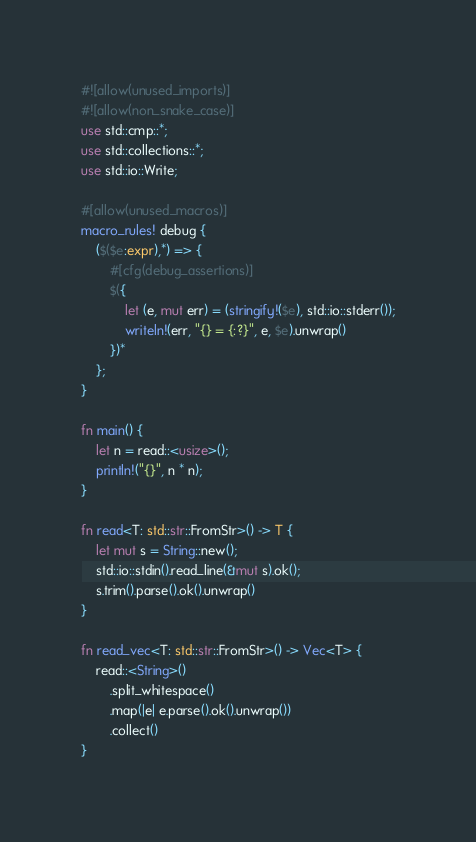Convert code to text. <code><loc_0><loc_0><loc_500><loc_500><_Rust_>#![allow(unused_imports)]
#![allow(non_snake_case)]
use std::cmp::*;
use std::collections::*;
use std::io::Write;

#[allow(unused_macros)]
macro_rules! debug {
    ($($e:expr),*) => {
        #[cfg(debug_assertions)]
        $({
            let (e, mut err) = (stringify!($e), std::io::stderr());
            writeln!(err, "{} = {:?}", e, $e).unwrap()
        })*
    };
}

fn main() {
    let n = read::<usize>();
    println!("{}", n * n);
}

fn read<T: std::str::FromStr>() -> T {
    let mut s = String::new();
    std::io::stdin().read_line(&mut s).ok();
    s.trim().parse().ok().unwrap()
}

fn read_vec<T: std::str::FromStr>() -> Vec<T> {
    read::<String>()
        .split_whitespace()
        .map(|e| e.parse().ok().unwrap())
        .collect()
}
</code> 